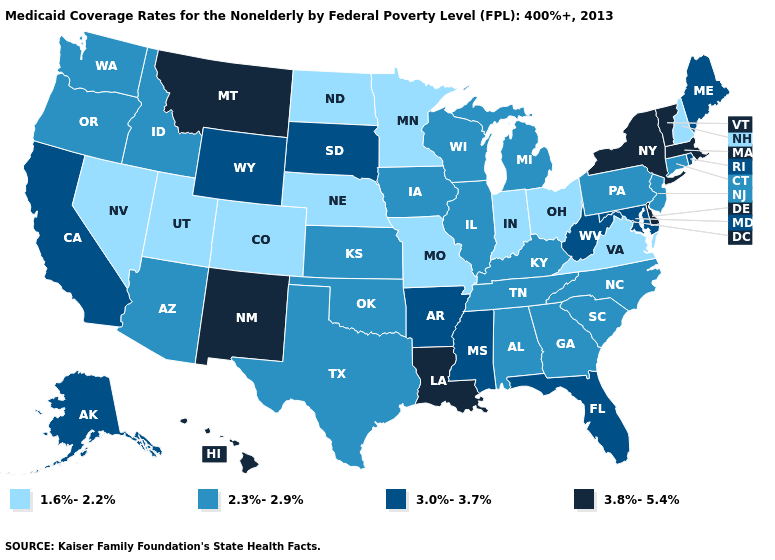Among the states that border Illinois , which have the lowest value?
Write a very short answer. Indiana, Missouri. What is the value of Alabama?
Short answer required. 2.3%-2.9%. What is the lowest value in the South?
Be succinct. 1.6%-2.2%. Does the first symbol in the legend represent the smallest category?
Be succinct. Yes. Name the states that have a value in the range 3.0%-3.7%?
Short answer required. Alaska, Arkansas, California, Florida, Maine, Maryland, Mississippi, Rhode Island, South Dakota, West Virginia, Wyoming. Does Colorado have the lowest value in the West?
Write a very short answer. Yes. Name the states that have a value in the range 3.8%-5.4%?
Be succinct. Delaware, Hawaii, Louisiana, Massachusetts, Montana, New Mexico, New York, Vermont. Does Wisconsin have a higher value than Idaho?
Write a very short answer. No. Name the states that have a value in the range 1.6%-2.2%?
Be succinct. Colorado, Indiana, Minnesota, Missouri, Nebraska, Nevada, New Hampshire, North Dakota, Ohio, Utah, Virginia. What is the highest value in the West ?
Answer briefly. 3.8%-5.4%. Does Colorado have the lowest value in the USA?
Write a very short answer. Yes. Does Colorado have the same value as North Dakota?
Quick response, please. Yes. Does South Dakota have the highest value in the USA?
Give a very brief answer. No. Name the states that have a value in the range 3.8%-5.4%?
Write a very short answer. Delaware, Hawaii, Louisiana, Massachusetts, Montana, New Mexico, New York, Vermont. Does the first symbol in the legend represent the smallest category?
Answer briefly. Yes. 